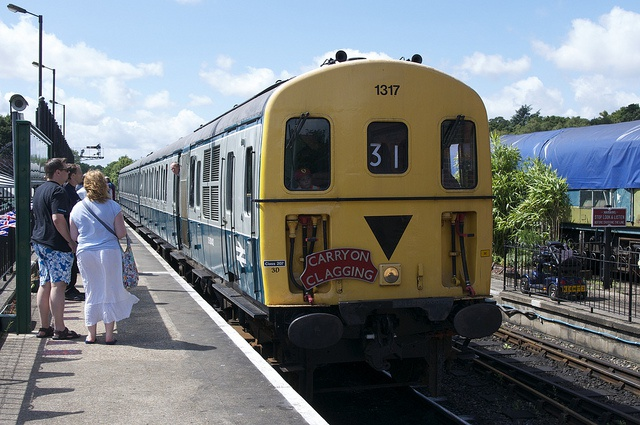Describe the objects in this image and their specific colors. I can see train in lightblue, black, olive, and gray tones, people in lightblue, gray, and darkgray tones, people in lightblue, black, gray, and navy tones, car in lightblue, black, gray, navy, and maroon tones, and handbag in lightblue, gray, navy, and blue tones in this image. 